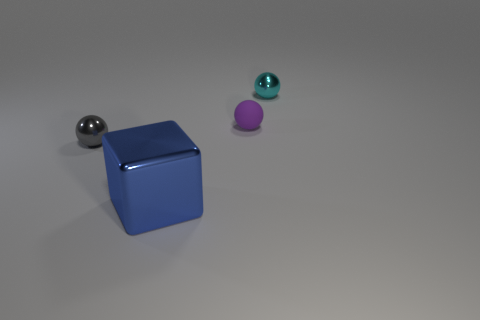Subtract all gray spheres. How many spheres are left? 2 Subtract all gray balls. How many balls are left? 2 Add 4 brown metallic balls. How many objects exist? 8 Subtract 0 yellow balls. How many objects are left? 4 Subtract all cubes. How many objects are left? 3 Subtract 3 balls. How many balls are left? 0 Subtract all gray blocks. Subtract all cyan cylinders. How many blocks are left? 1 Subtract all yellow cylinders. How many yellow cubes are left? 0 Subtract all purple rubber blocks. Subtract all matte things. How many objects are left? 3 Add 2 small purple balls. How many small purple balls are left? 3 